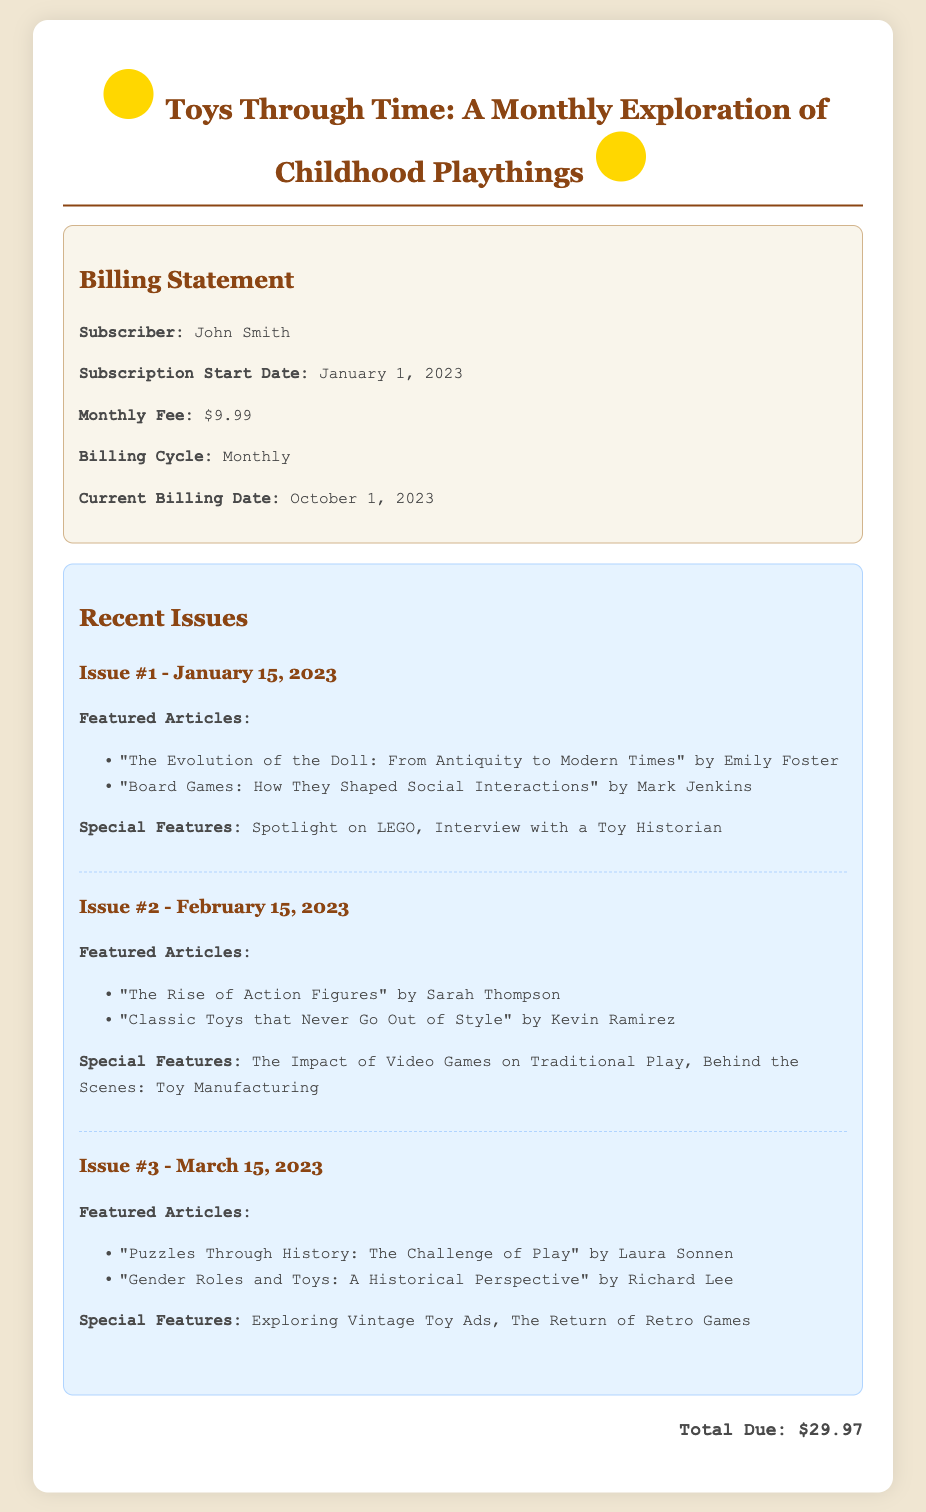What is the name of the magazine? The name of the magazine is mentioned in the header of the document.
Answer: Toys Through Time Who is the subscriber? The document provides specific billing information, including the subscriber's name.
Answer: John Smith What is the monthly fee for the subscription? The monthly fee is explicitly stated in the billing information section of the document.
Answer: $9.99 When was the current billing date? The current billing date is specified in the billing information section.
Answer: October 1, 2023 How many issues are highlighted in the recent issues section? The document lists the number of issues featured, which can be counted.
Answer: 3 Which article was featured in the first issue? The first issue's featured articles are listed; the first one can be directly referenced.
Answer: "The Evolution of the Doll: From Antiquity to Modern Times" What is the total due amount mentioned in the document? The total due is the final amount specified in the billing statement.
Answer: $29.97 What is the title of the feature in the second issue? The special features for each issue are mentioned, with the second issue having a specific title.
Answer: The Impact of Video Games on Traditional Play Who wrote the article on gender roles and toys? The author of the article is given in the featured articles list of the third issue.
Answer: Richard Lee 